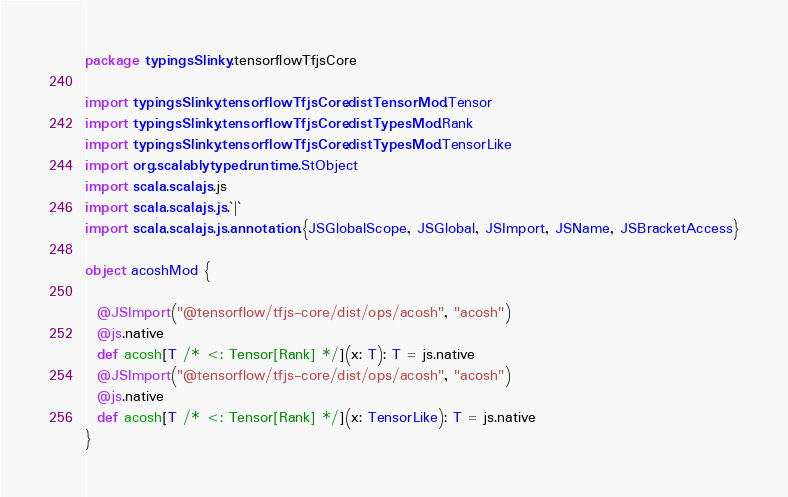<code> <loc_0><loc_0><loc_500><loc_500><_Scala_>package typingsSlinky.tensorflowTfjsCore

import typingsSlinky.tensorflowTfjsCore.distTensorMod.Tensor
import typingsSlinky.tensorflowTfjsCore.distTypesMod.Rank
import typingsSlinky.tensorflowTfjsCore.distTypesMod.TensorLike
import org.scalablytyped.runtime.StObject
import scala.scalajs.js
import scala.scalajs.js.`|`
import scala.scalajs.js.annotation.{JSGlobalScope, JSGlobal, JSImport, JSName, JSBracketAccess}

object acoshMod {
  
  @JSImport("@tensorflow/tfjs-core/dist/ops/acosh", "acosh")
  @js.native
  def acosh[T /* <: Tensor[Rank] */](x: T): T = js.native
  @JSImport("@tensorflow/tfjs-core/dist/ops/acosh", "acosh")
  @js.native
  def acosh[T /* <: Tensor[Rank] */](x: TensorLike): T = js.native
}
</code> 